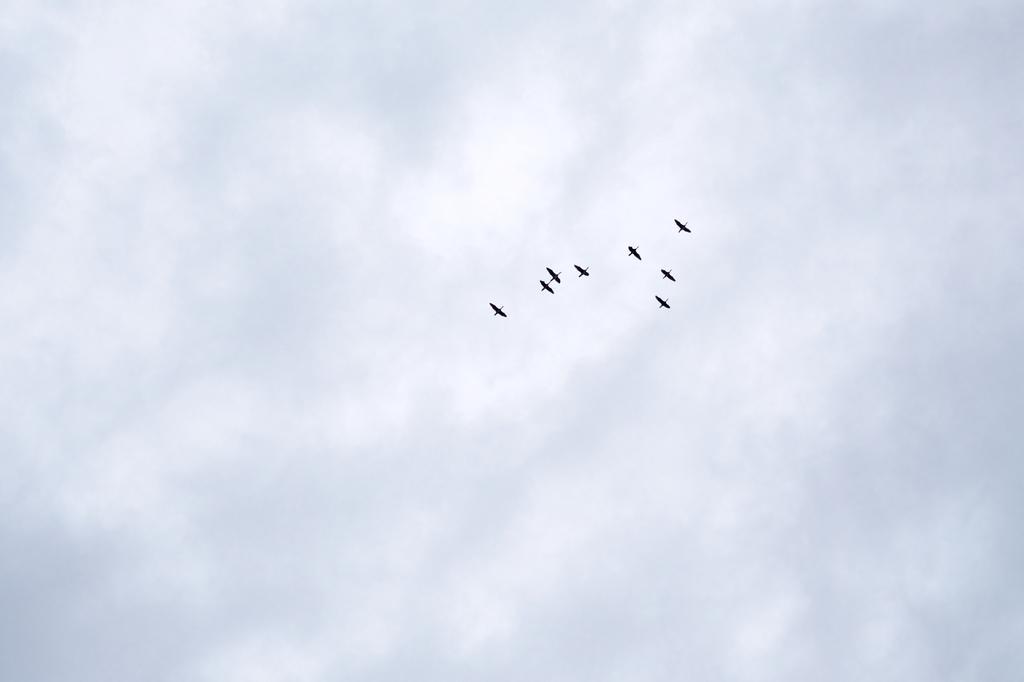Describe this image in one or two sentences. In this image we can see some birds are flying and in the background, we can see the sky with clouds. 